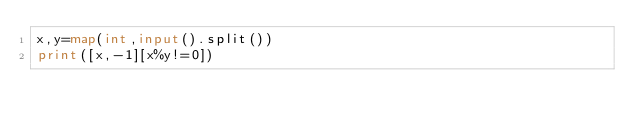Convert code to text. <code><loc_0><loc_0><loc_500><loc_500><_Python_>x,y=map(int,input().split())
print([x,-1][x%y!=0])</code> 